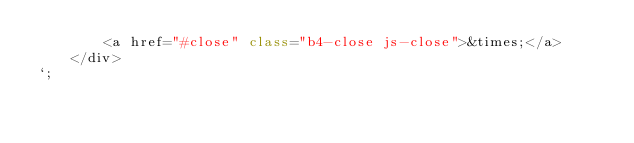Convert code to text. <code><loc_0><loc_0><loc_500><loc_500><_JavaScript_>        <a href="#close" class="b4-close js-close">&times;</a>
    </div>
`;
</code> 